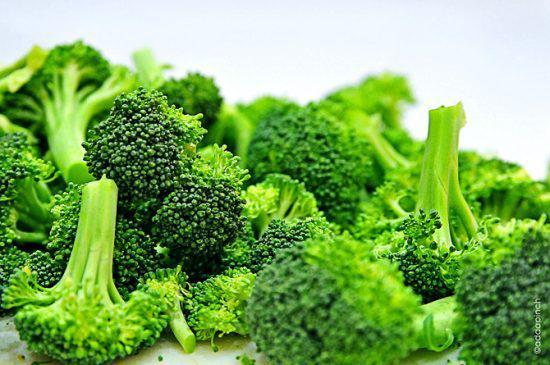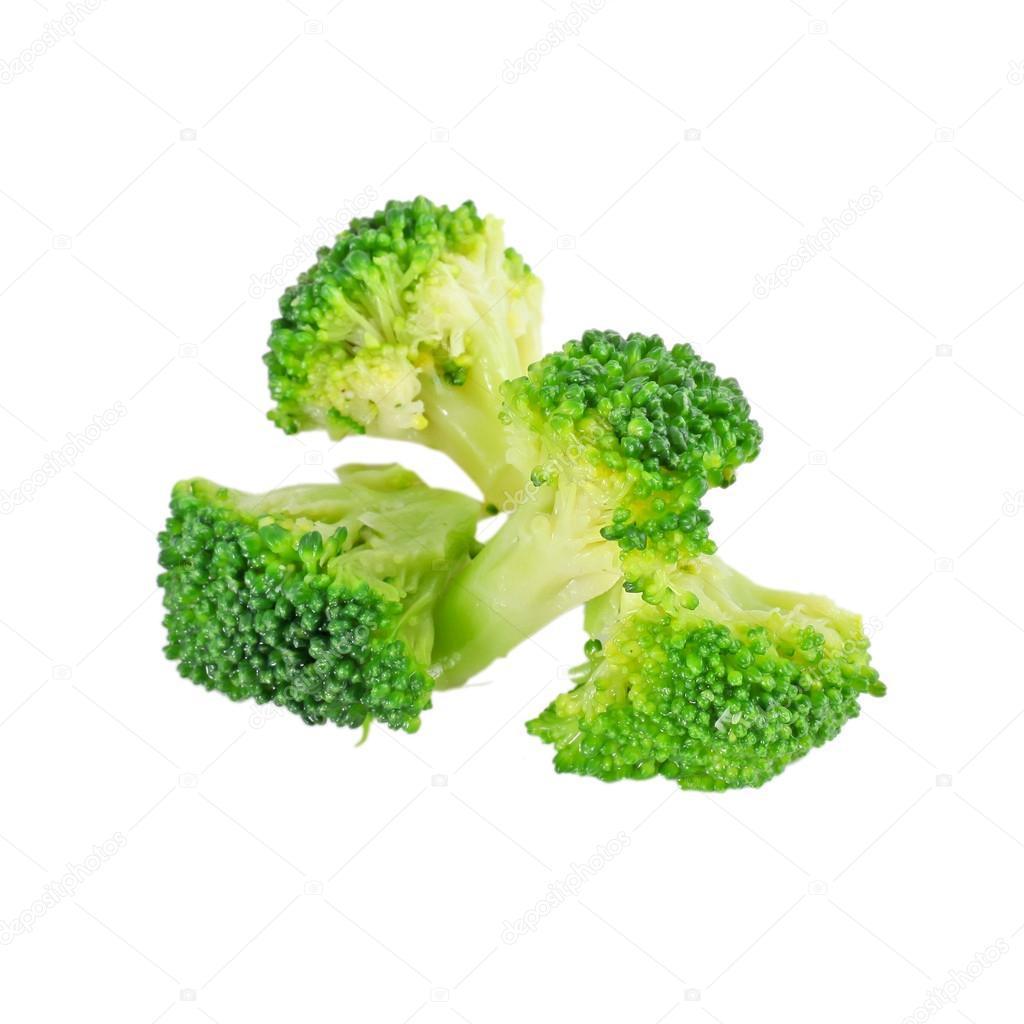The first image is the image on the left, the second image is the image on the right. Considering the images on both sides, is "There are no more than four broccoli pieces" valid? Answer yes or no. No. 